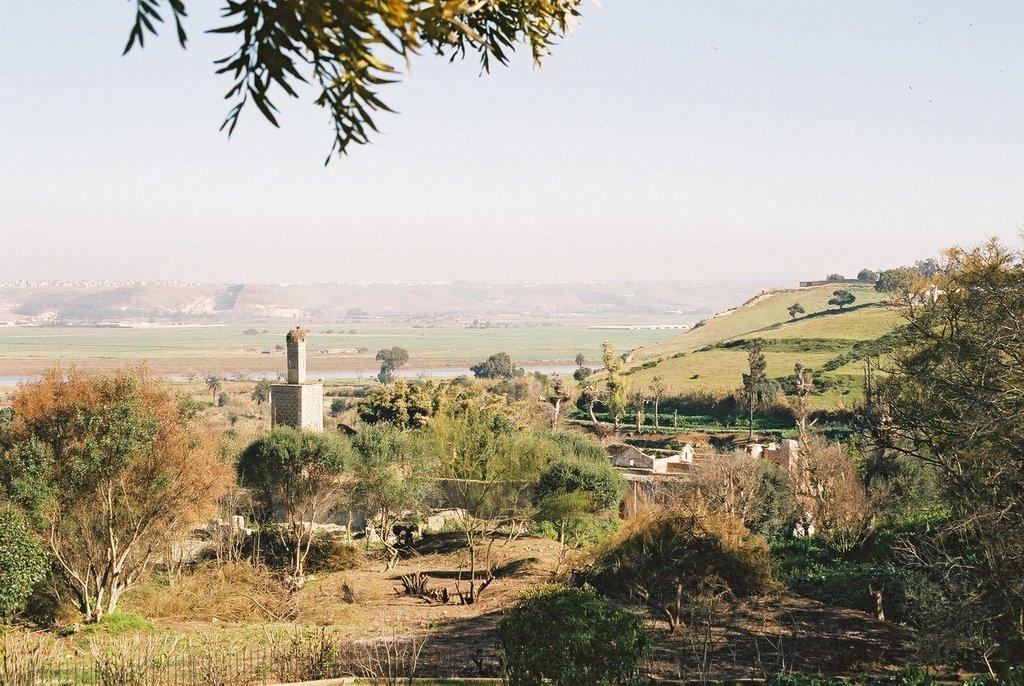Can you describe this image briefly? In this image we can see group of buildings placed on the ground. In the background we can see group of trees, mountains and sky. 